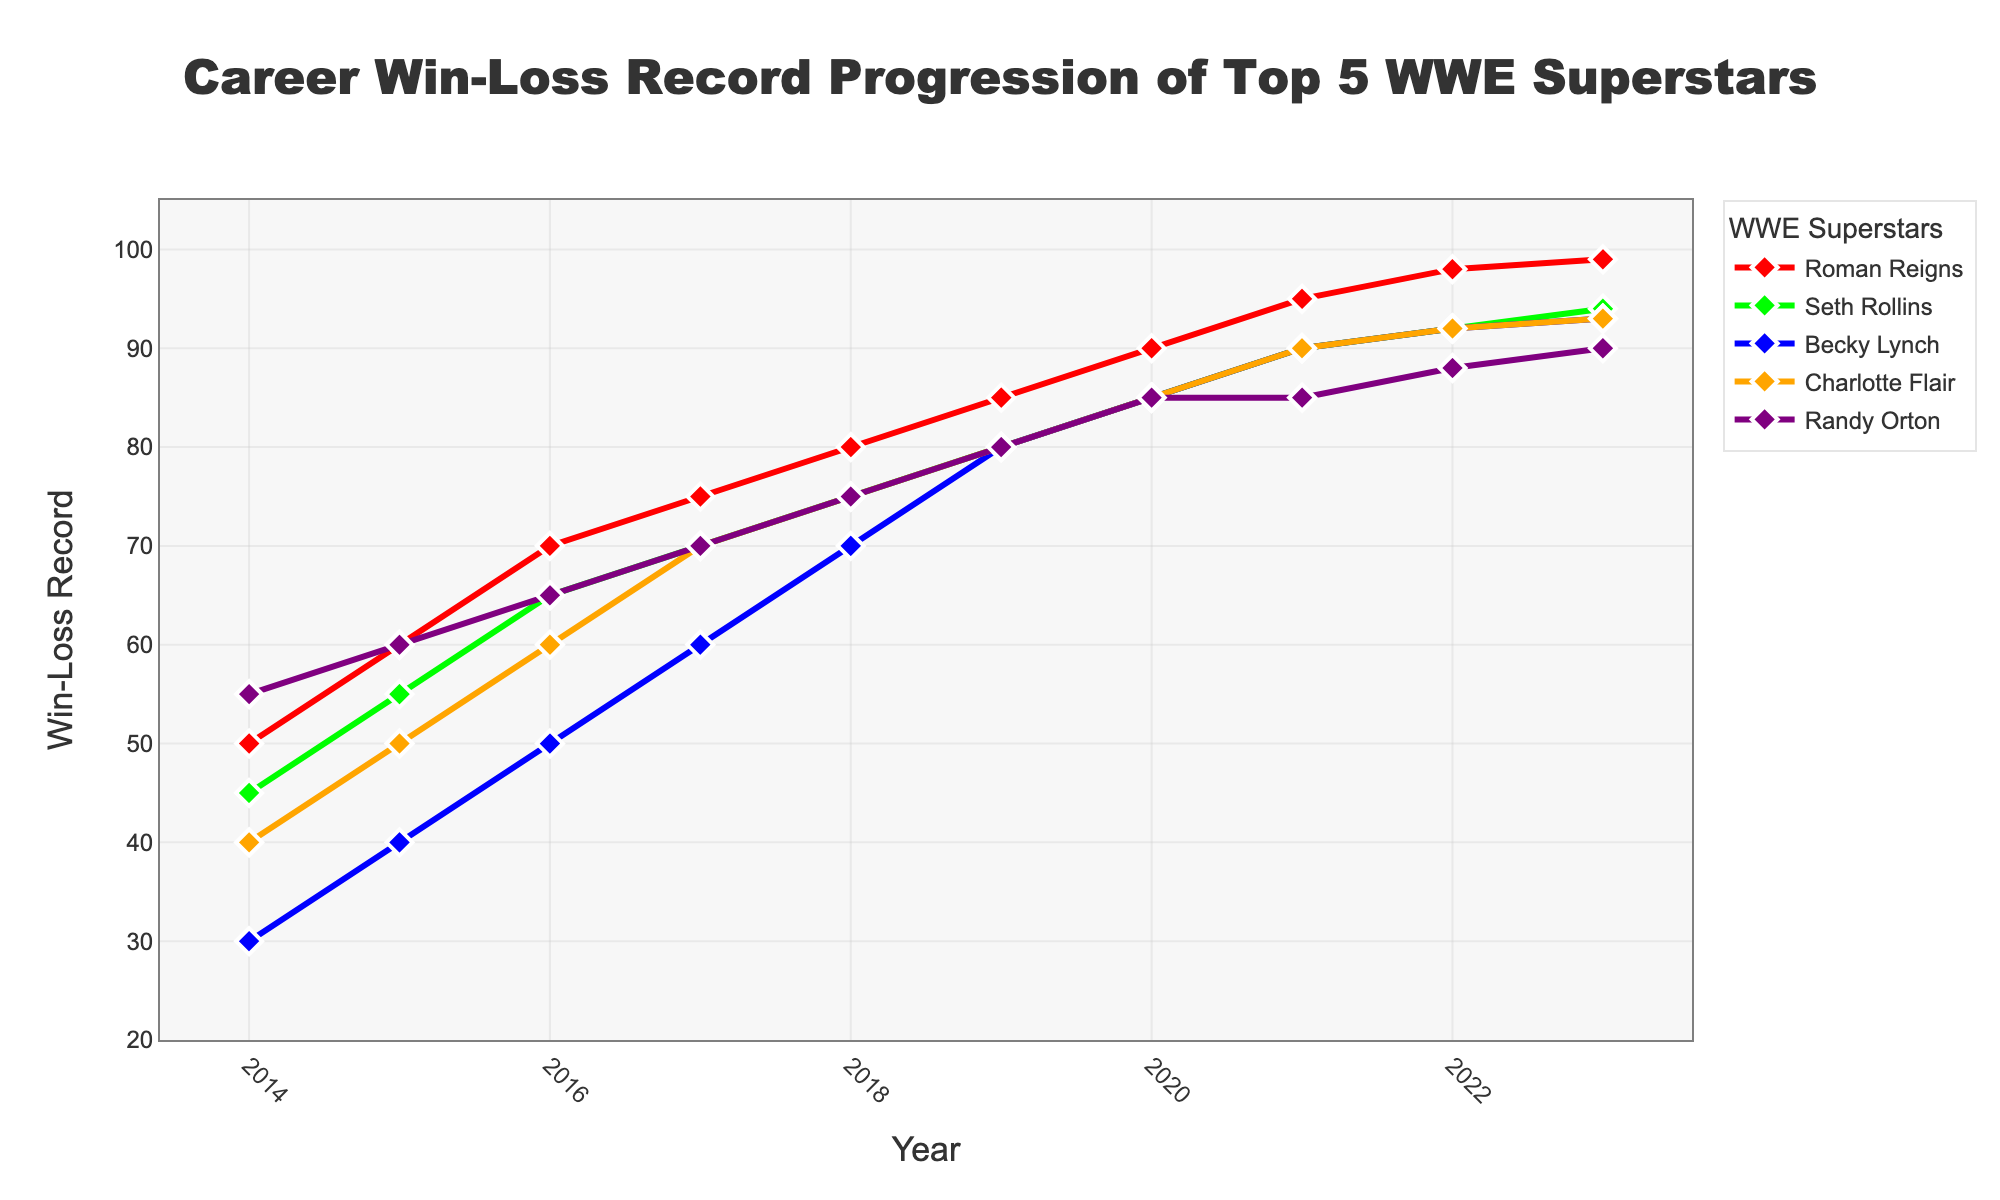what is the win-loss record of Roman Reigns in 2023? Roman Reigns's win-loss record in 2023 is the data point for that year. Check the 'Roman Reigns' line for 2023.
Answer: 99 Who had the highest win-loss record in 2014? In the year 2014, compare the win-loss records of all five superstars. Roman Reigns had 50, Seth Rollins had 45, Becky Lynch had 30, Charlotte Flair had 40, and Randy Orton had 55. Randy Orton's record of 55 is the highest.
Answer: Randy Orton Did Becky Lynch ever surpass Charlotte Flair in win-loss records? Compare Becky Lynch's win-loss records with Charlotte Flair's across the years. Becky Lynch's record surpasses Charlotte Flair's starting in 2019 and maintained until 2023.
Answer: Yes What is the average win-loss record of Seth Rollins from 2014 to 2023? Calculate the sum of Seth Rollins' records from 2014 to 2023, which are: 45, 55, 65, 70, 75, 80, 85, 90, 92, and 94. The sum is 751. Divide by the number of years (10) for the average. \(751 / 10 = 75.1\)
Answer: 75.1 Between 2017 and 2019, who showed the most improvement in win-loss record, and by how much? Calculate the differences between the win-loss records in 2017 and 2019 for each superstar:
Roman Reigns (85-75=10), 
Seth Rollins (80-70=10), 
Becky Lynch (80-60=20),
Charlotte Flair (80-70=10), 
Randy Orton (80-70=10). Becky Lynch showed the most improvement with a gain of 20.
Answer: Becky Lynch, 20 Whose win-loss record was the same in 2018 and 2019? Compare each superstar's win-loss record in 2018 and 2019. Roman Reigns' record increased from 80 to 85, Seth Rollins’ from 75 to 80, Becky Lynch’s from 70 to 80, Charlotte Flair’s from 75 to 80, and Randy Orton had 80 for both years.
Answer: Randy Orton Which superstar has the smallest increase in win-loss record from 2019 to 2023? Calculate the differences between 2019 and 2023 for each superstar:
Roman Reigns (99-85=14),
Seth Rollins (94-80=14),
Becky Lynch (93-80=13),
Charlotte Flair (93-80=13),
Randy Orton (90-80=10). Randy Orton had the smallest increase of 10.
Answer: Randy Orton What's the trend for Charlotte Flair's win-loss record from 2014 to 2023? Observing the line corresponding to Charlotte Flair, we see a year-over-year increase in her win-loss record, rising steadily from 40 in 2014 to 93 in 2023.
Answer: Increasing Compare the win-loss records of Roman Reigns and Seth Rollins across all the years. Who had a more consistent increase? Both Roman Reigns and Seth Rollins show an increasing trend, but Roman Reigns’ jumps are more uniform year to year, suggesting a more consistent increase compared to Seth Rollins whose increments vary more.
Answer: Roman Reigns 